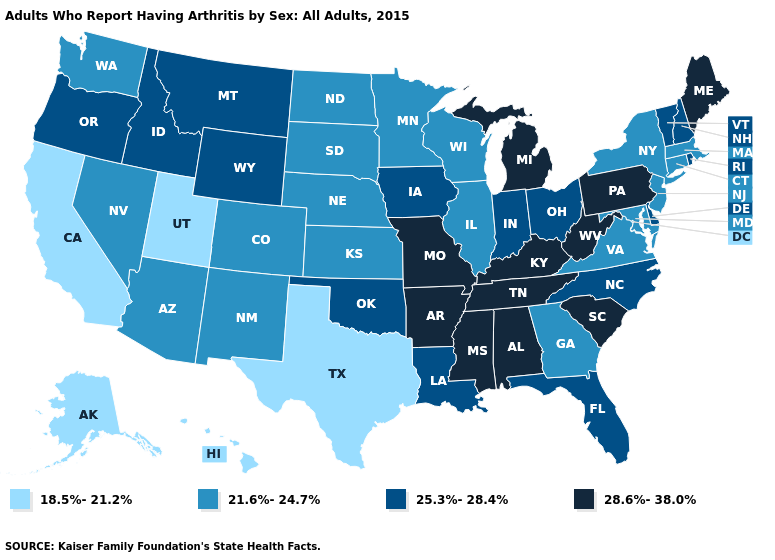What is the highest value in states that border Connecticut?
Write a very short answer. 25.3%-28.4%. What is the lowest value in the USA?
Keep it brief. 18.5%-21.2%. Which states have the lowest value in the USA?
Concise answer only. Alaska, California, Hawaii, Texas, Utah. What is the highest value in the USA?
Quick response, please. 28.6%-38.0%. Among the states that border Massachusetts , which have the lowest value?
Quick response, please. Connecticut, New York. What is the highest value in states that border Nebraska?
Give a very brief answer. 28.6%-38.0%. What is the value of Missouri?
Answer briefly. 28.6%-38.0%. Name the states that have a value in the range 25.3%-28.4%?
Answer briefly. Delaware, Florida, Idaho, Indiana, Iowa, Louisiana, Montana, New Hampshire, North Carolina, Ohio, Oklahoma, Oregon, Rhode Island, Vermont, Wyoming. What is the value of Rhode Island?
Keep it brief. 25.3%-28.4%. Which states hav the highest value in the MidWest?
Answer briefly. Michigan, Missouri. Which states hav the highest value in the MidWest?
Give a very brief answer. Michigan, Missouri. Does Pennsylvania have the highest value in the USA?
Concise answer only. Yes. What is the highest value in the West ?
Write a very short answer. 25.3%-28.4%. What is the value of North Carolina?
Concise answer only. 25.3%-28.4%. 